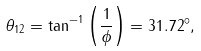Convert formula to latex. <formula><loc_0><loc_0><loc_500><loc_500>\theta _ { 1 2 } = \tan ^ { - 1 } \left ( \frac { 1 } { \phi } \right ) = 3 1 . 7 2 ^ { \circ } ,</formula> 